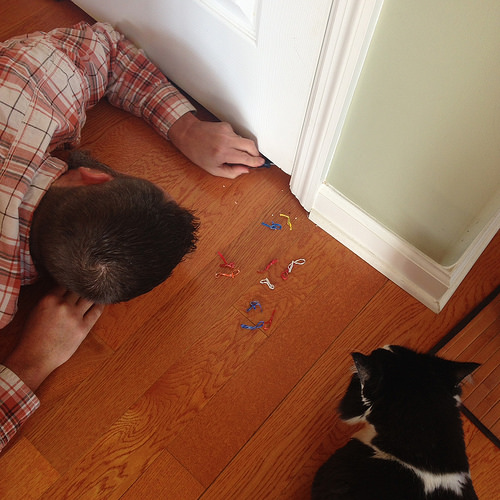<image>
Can you confirm if the dog is on the floor? Yes. Looking at the image, I can see the dog is positioned on top of the floor, with the floor providing support. 